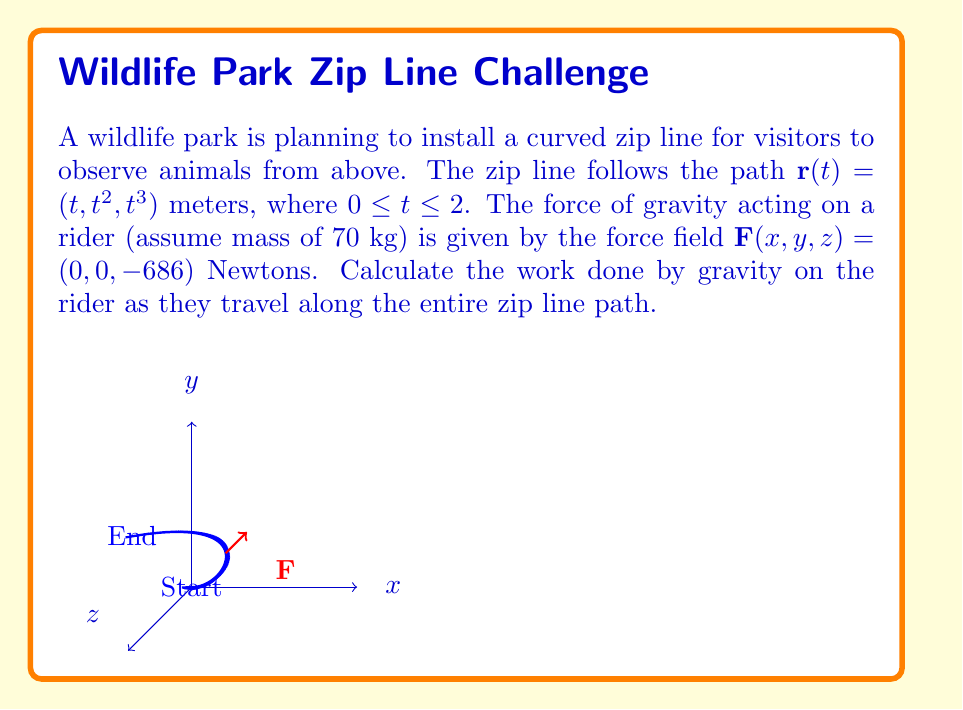Solve this math problem. Let's approach this step-by-step:

1) The work done by a force field $\mathbf{F}(x,y,z)$ along a path $\mathbf{r}(t)$ from $t=a$ to $t=b$ is given by the line integral:

   $W = \int_a^b \mathbf{F}(\mathbf{r}(t)) \cdot \frac{d\mathbf{r}}{dt} dt$

2) We have:
   $\mathbf{F}(x,y,z) = (0, 0, -686)$
   $\mathbf{r}(t) = (t, t^2, t^3)$
   $a = 0$, $b = 2$

3) We need to calculate $\frac{d\mathbf{r}}{dt}$:
   $\frac{d\mathbf{r}}{dt} = (1, 2t, 3t^2)$

4) Now, let's compute the dot product inside the integral:
   $\mathbf{F}(\mathbf{r}(t)) \cdot \frac{d\mathbf{r}}{dt} = (0, 0, -686) \cdot (1, 2t, 3t^2) = -2058t^2$

5) Our integral becomes:
   $W = \int_0^2 -2058t^2 dt$

6) Integrating:
   $W = -2058 \cdot \frac{t^3}{3} \Big|_0^2$

7) Evaluating the limits:
   $W = -2058 \cdot \frac{8}{3} - 0 = -5488$ Joules

The negative sign indicates that the work is done against gravity (the rider gains potential energy).
Answer: $-5488$ J 